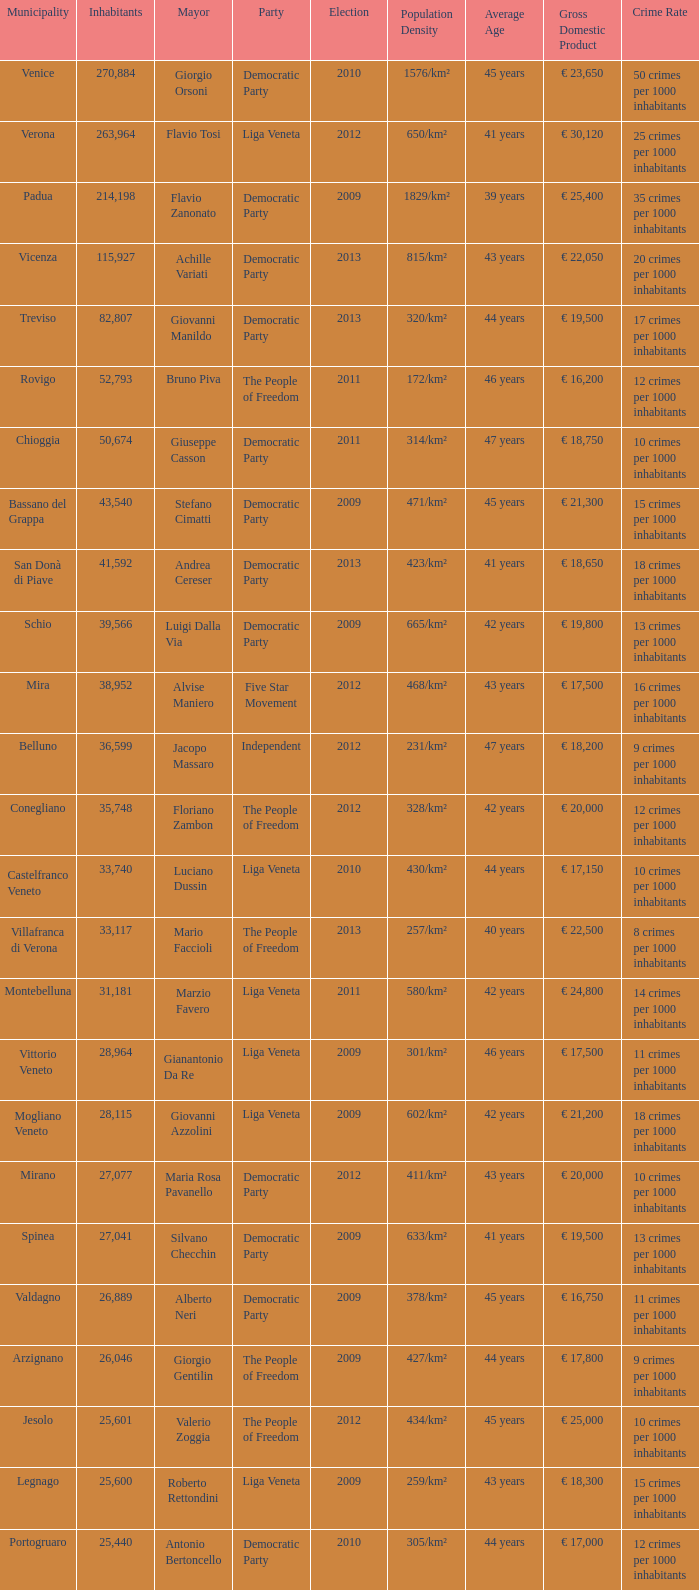What party was achille variati afilliated with? Democratic Party. 